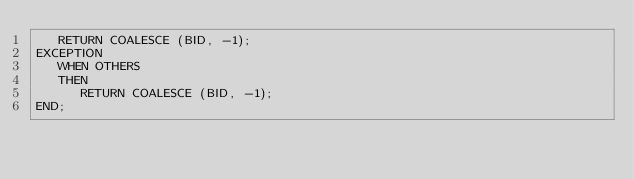Convert code to text. <code><loc_0><loc_0><loc_500><loc_500><_SQL_>   RETURN COALESCE (BID, -1);
EXCEPTION
   WHEN OTHERS
   THEN
      RETURN COALESCE (BID, -1);
END;</code> 